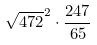<formula> <loc_0><loc_0><loc_500><loc_500>\sqrt { 4 7 2 } ^ { 2 } \cdot \frac { 2 4 7 } { 6 5 }</formula> 